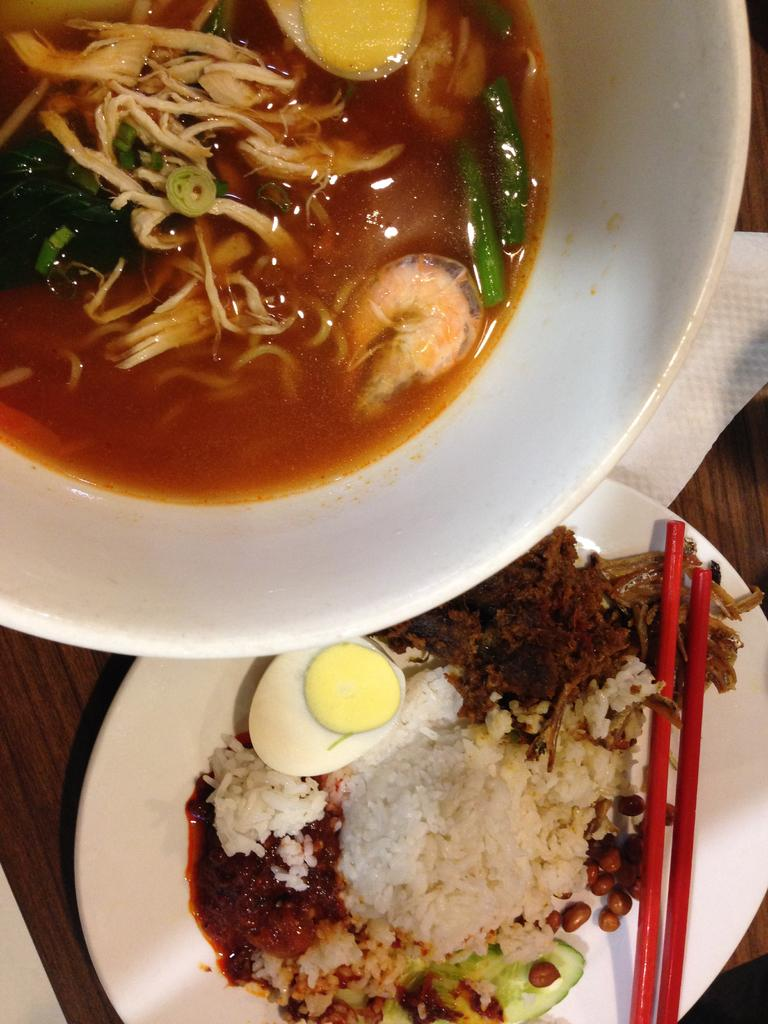What type of food items can be seen in the image? There are food items in bowls and on plates in the image. Where are the bowls and plates located? The bowls and plates are on a table in the image. What utensils are visible in the image? Chopsticks are visible in the image. What might be used for cleaning or wiping in the image? Tissue papers are present in the image. What type of train can be seen in the image? There is no train present in the image; it features related to food and dining are the focus. 